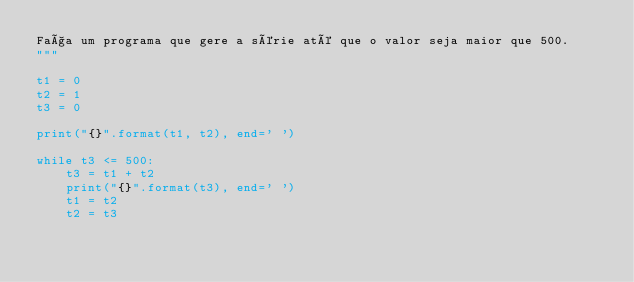Convert code to text. <code><loc_0><loc_0><loc_500><loc_500><_Python_>Faça um programa que gere a série até que o valor seja maior que 500.
"""

t1 = 0
t2 = 1
t3 = 0

print("{}".format(t1, t2), end=' ')

while t3 <= 500:
    t3 = t1 + t2
    print("{}".format(t3), end=' ')
    t1 = t2
    t2 = t3
</code> 